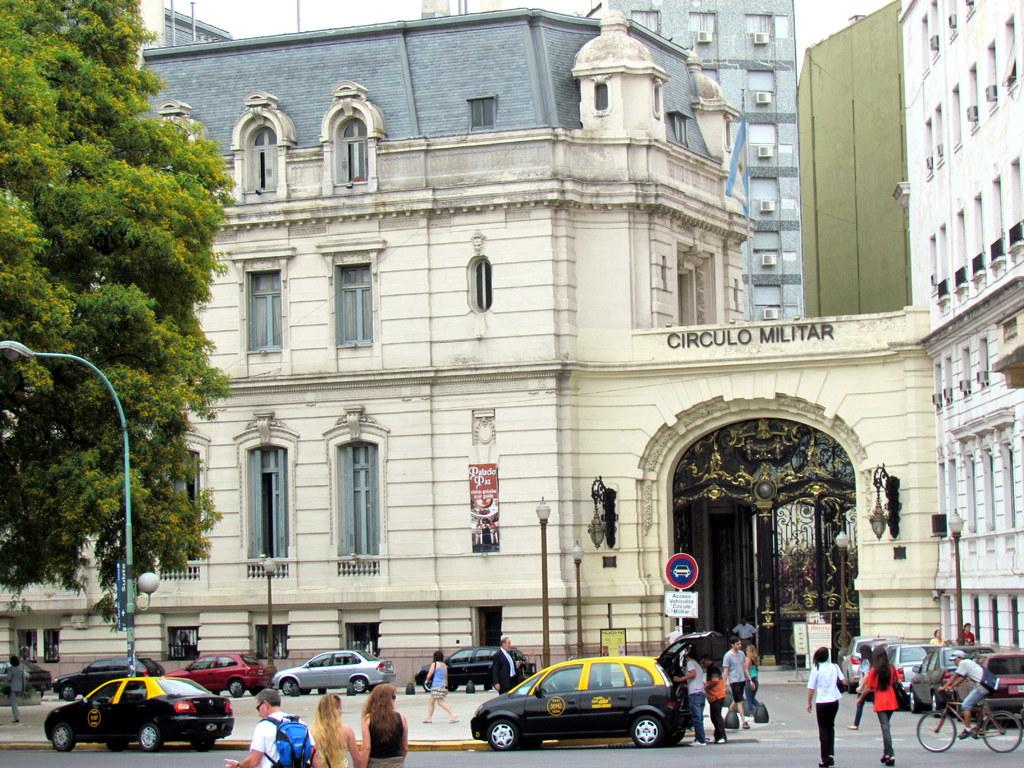<image>
Offer a succinct explanation of the picture presented. a street scene of an old building named Circulo Militar 